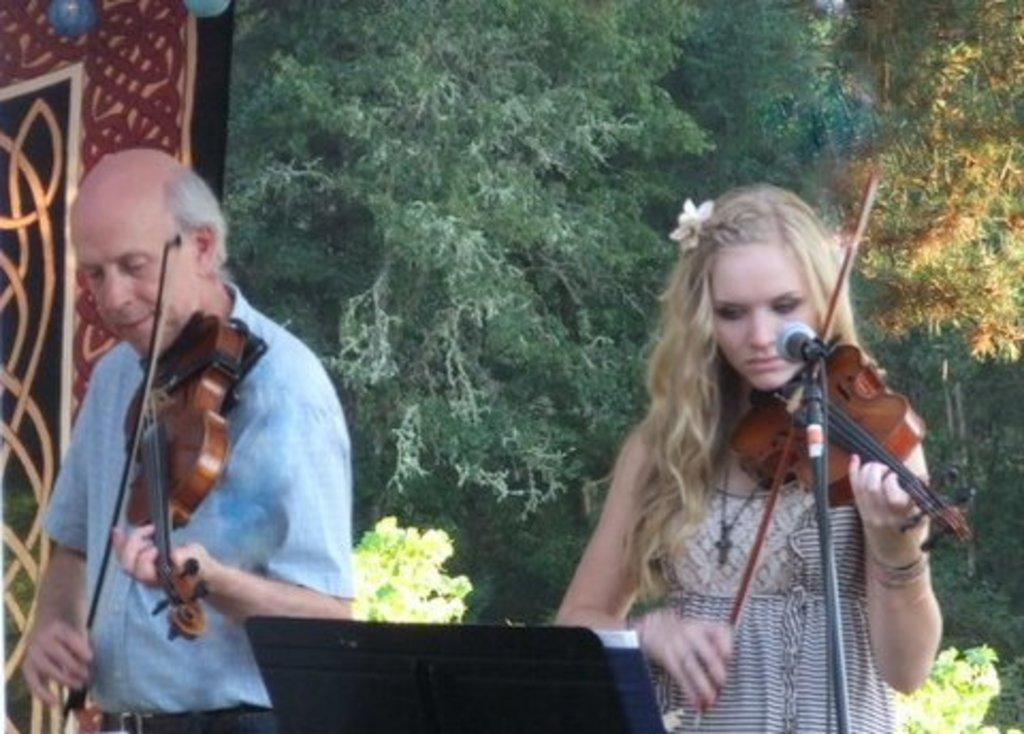How many people are in the image? There are two people in the image. What are the people doing in the image? The presence of musical instruments suggests that the people might be playing music. What else can be seen in the image besides the people? There are objects in the image, which could be other musical instruments or related items. What can be seen in the background of the image? There are trees in the background of the image. Can you tell me how many apples are on the floor in the image? There is no mention of apples or a floor in the image, so it is not possible to answer that question. 